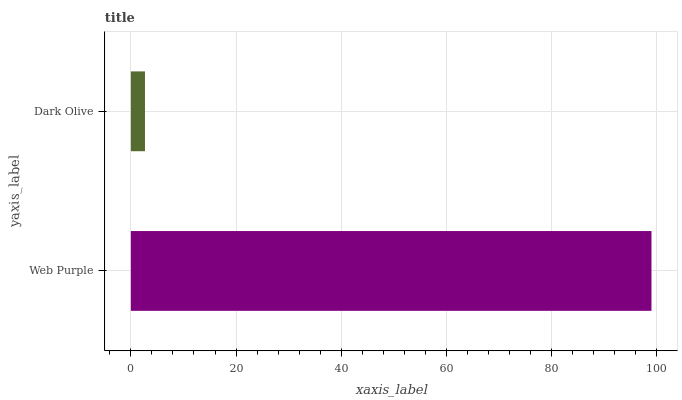Is Dark Olive the minimum?
Answer yes or no. Yes. Is Web Purple the maximum?
Answer yes or no. Yes. Is Dark Olive the maximum?
Answer yes or no. No. Is Web Purple greater than Dark Olive?
Answer yes or no. Yes. Is Dark Olive less than Web Purple?
Answer yes or no. Yes. Is Dark Olive greater than Web Purple?
Answer yes or no. No. Is Web Purple less than Dark Olive?
Answer yes or no. No. Is Web Purple the high median?
Answer yes or no. Yes. Is Dark Olive the low median?
Answer yes or no. Yes. Is Dark Olive the high median?
Answer yes or no. No. Is Web Purple the low median?
Answer yes or no. No. 